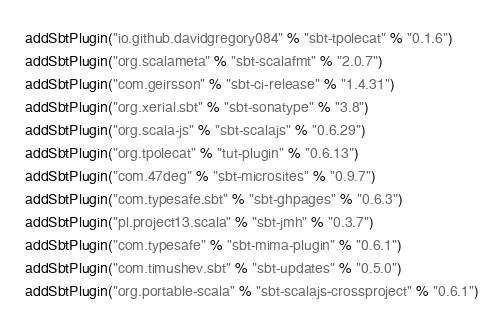Convert code to text. <code><loc_0><loc_0><loc_500><loc_500><_Scala_>addSbtPlugin("io.github.davidgregory084" % "sbt-tpolecat" % "0.1.6")
addSbtPlugin("org.scalameta" % "sbt-scalafmt" % "2.0.7")
addSbtPlugin("com.geirsson" % "sbt-ci-release" % "1.4.31")
addSbtPlugin("org.xerial.sbt" % "sbt-sonatype" % "3.8")
addSbtPlugin("org.scala-js" % "sbt-scalajs" % "0.6.29")
addSbtPlugin("org.tpolecat" % "tut-plugin" % "0.6.13")
addSbtPlugin("com.47deg" % "sbt-microsites" % "0.9.7")
addSbtPlugin("com.typesafe.sbt" % "sbt-ghpages" % "0.6.3")
addSbtPlugin("pl.project13.scala" % "sbt-jmh" % "0.3.7")
addSbtPlugin("com.typesafe" % "sbt-mima-plugin" % "0.6.1")
addSbtPlugin("com.timushev.sbt" % "sbt-updates" % "0.5.0")
addSbtPlugin("org.portable-scala" % "sbt-scalajs-crossproject" % "0.6.1")</code> 